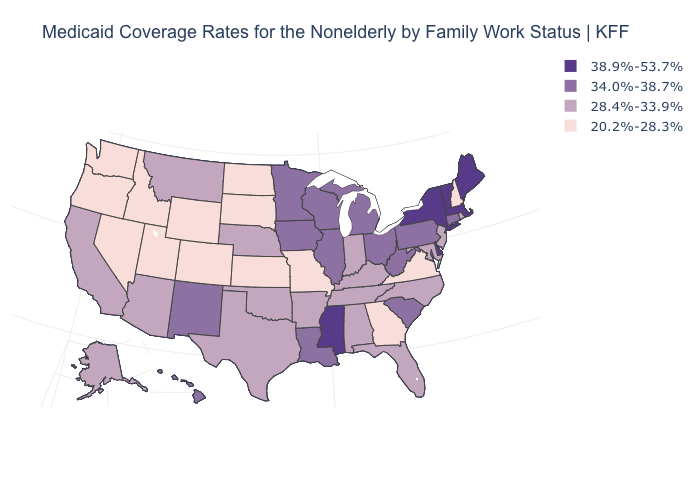What is the value of Maine?
Answer briefly. 38.9%-53.7%. Name the states that have a value in the range 38.9%-53.7%?
Write a very short answer. Delaware, Maine, Massachusetts, Mississippi, New York, Vermont. Among the states that border Maryland , does Delaware have the highest value?
Keep it brief. Yes. What is the value of Oklahoma?
Keep it brief. 28.4%-33.9%. What is the lowest value in the USA?
Be succinct. 20.2%-28.3%. Which states hav the highest value in the West?
Give a very brief answer. Hawaii, New Mexico. Is the legend a continuous bar?
Be succinct. No. Which states hav the highest value in the West?
Be succinct. Hawaii, New Mexico. Among the states that border Vermont , which have the lowest value?
Answer briefly. New Hampshire. What is the value of Nevada?
Answer briefly. 20.2%-28.3%. Name the states that have a value in the range 28.4%-33.9%?
Write a very short answer. Alabama, Alaska, Arizona, Arkansas, California, Florida, Indiana, Kentucky, Maryland, Montana, Nebraska, New Jersey, North Carolina, Oklahoma, Rhode Island, Tennessee, Texas. Does Iowa have the highest value in the USA?
Give a very brief answer. No. Name the states that have a value in the range 28.4%-33.9%?
Write a very short answer. Alabama, Alaska, Arizona, Arkansas, California, Florida, Indiana, Kentucky, Maryland, Montana, Nebraska, New Jersey, North Carolina, Oklahoma, Rhode Island, Tennessee, Texas. Which states hav the highest value in the West?
Keep it brief. Hawaii, New Mexico. 